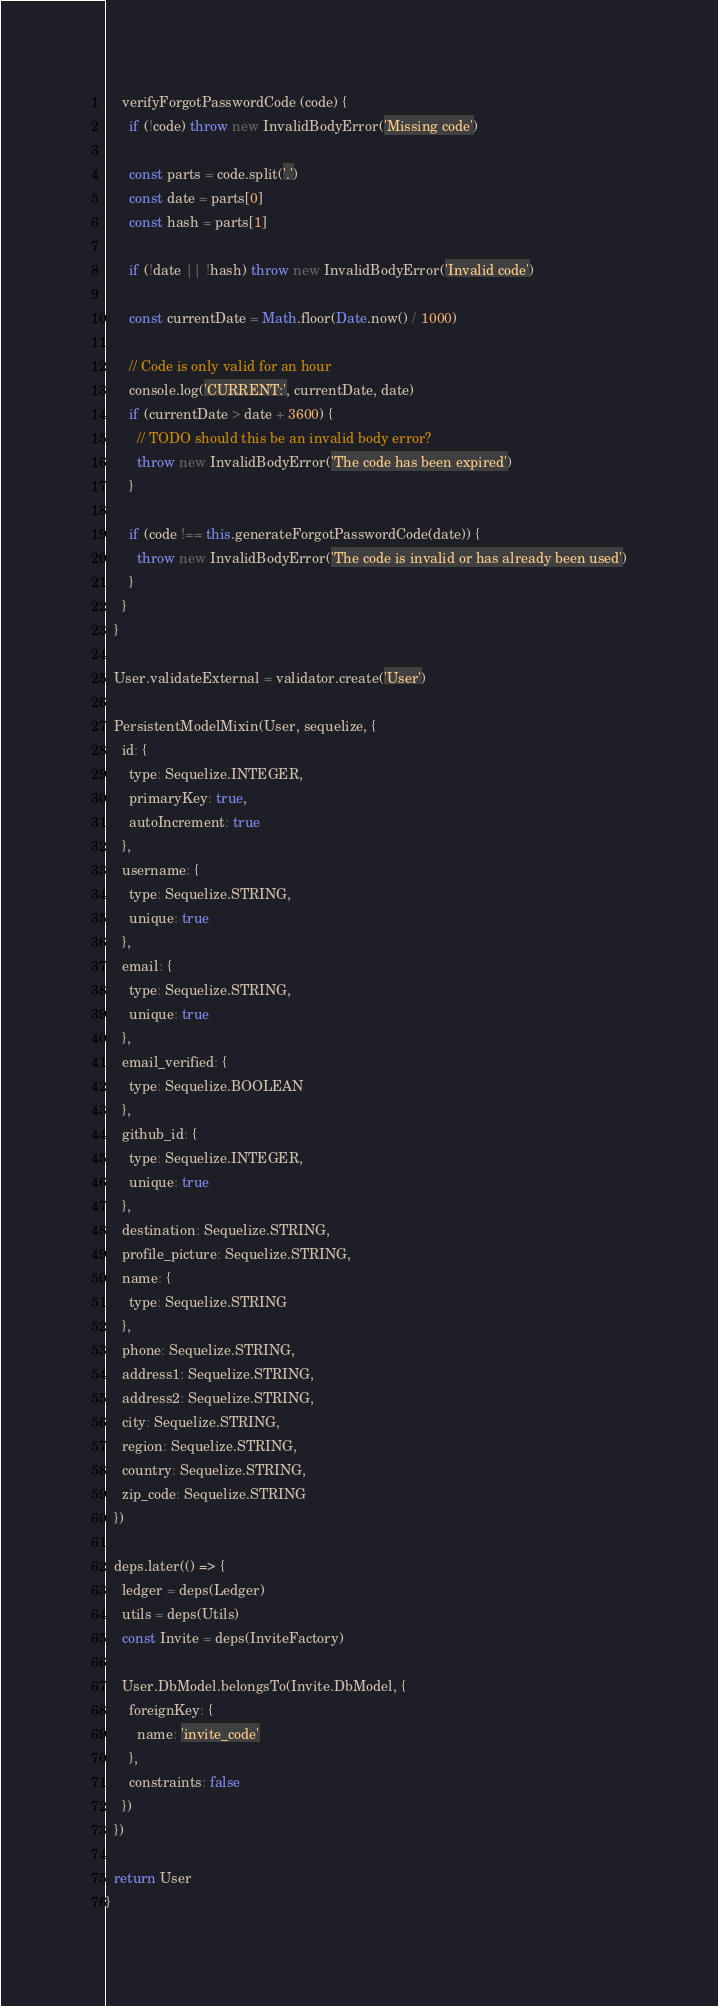<code> <loc_0><loc_0><loc_500><loc_500><_JavaScript_>
    verifyForgotPasswordCode (code) {
      if (!code) throw new InvalidBodyError('Missing code')

      const parts = code.split('.')
      const date = parts[0]
      const hash = parts[1]

      if (!date || !hash) throw new InvalidBodyError('Invalid code')

      const currentDate = Math.floor(Date.now() / 1000)

      // Code is only valid for an hour
      console.log('CURRENT:', currentDate, date)
      if (currentDate > date + 3600) {
        // TODO should this be an invalid body error?
        throw new InvalidBodyError('The code has been expired')
      }

      if (code !== this.generateForgotPasswordCode(date)) {
        throw new InvalidBodyError('The code is invalid or has already been used')
      }
    }
  }

  User.validateExternal = validator.create('User')

  PersistentModelMixin(User, sequelize, {
    id: {
      type: Sequelize.INTEGER,
      primaryKey: true,
      autoIncrement: true
    },
    username: {
      type: Sequelize.STRING,
      unique: true
    },
    email: {
      type: Sequelize.STRING,
      unique: true
    },
    email_verified: {
      type: Sequelize.BOOLEAN
    },
    github_id: {
      type: Sequelize.INTEGER,
      unique: true
    },
    destination: Sequelize.STRING,
    profile_picture: Sequelize.STRING,
    name: {
      type: Sequelize.STRING
    },
    phone: Sequelize.STRING,
    address1: Sequelize.STRING,
    address2: Sequelize.STRING,
    city: Sequelize.STRING,
    region: Sequelize.STRING,
    country: Sequelize.STRING,
    zip_code: Sequelize.STRING
  })

  deps.later(() => {
    ledger = deps(Ledger)
    utils = deps(Utils)
    const Invite = deps(InviteFactory)

    User.DbModel.belongsTo(Invite.DbModel, {
      foreignKey: {
        name: 'invite_code'
      },
      constraints: false
    })
  })

  return User
}
</code> 